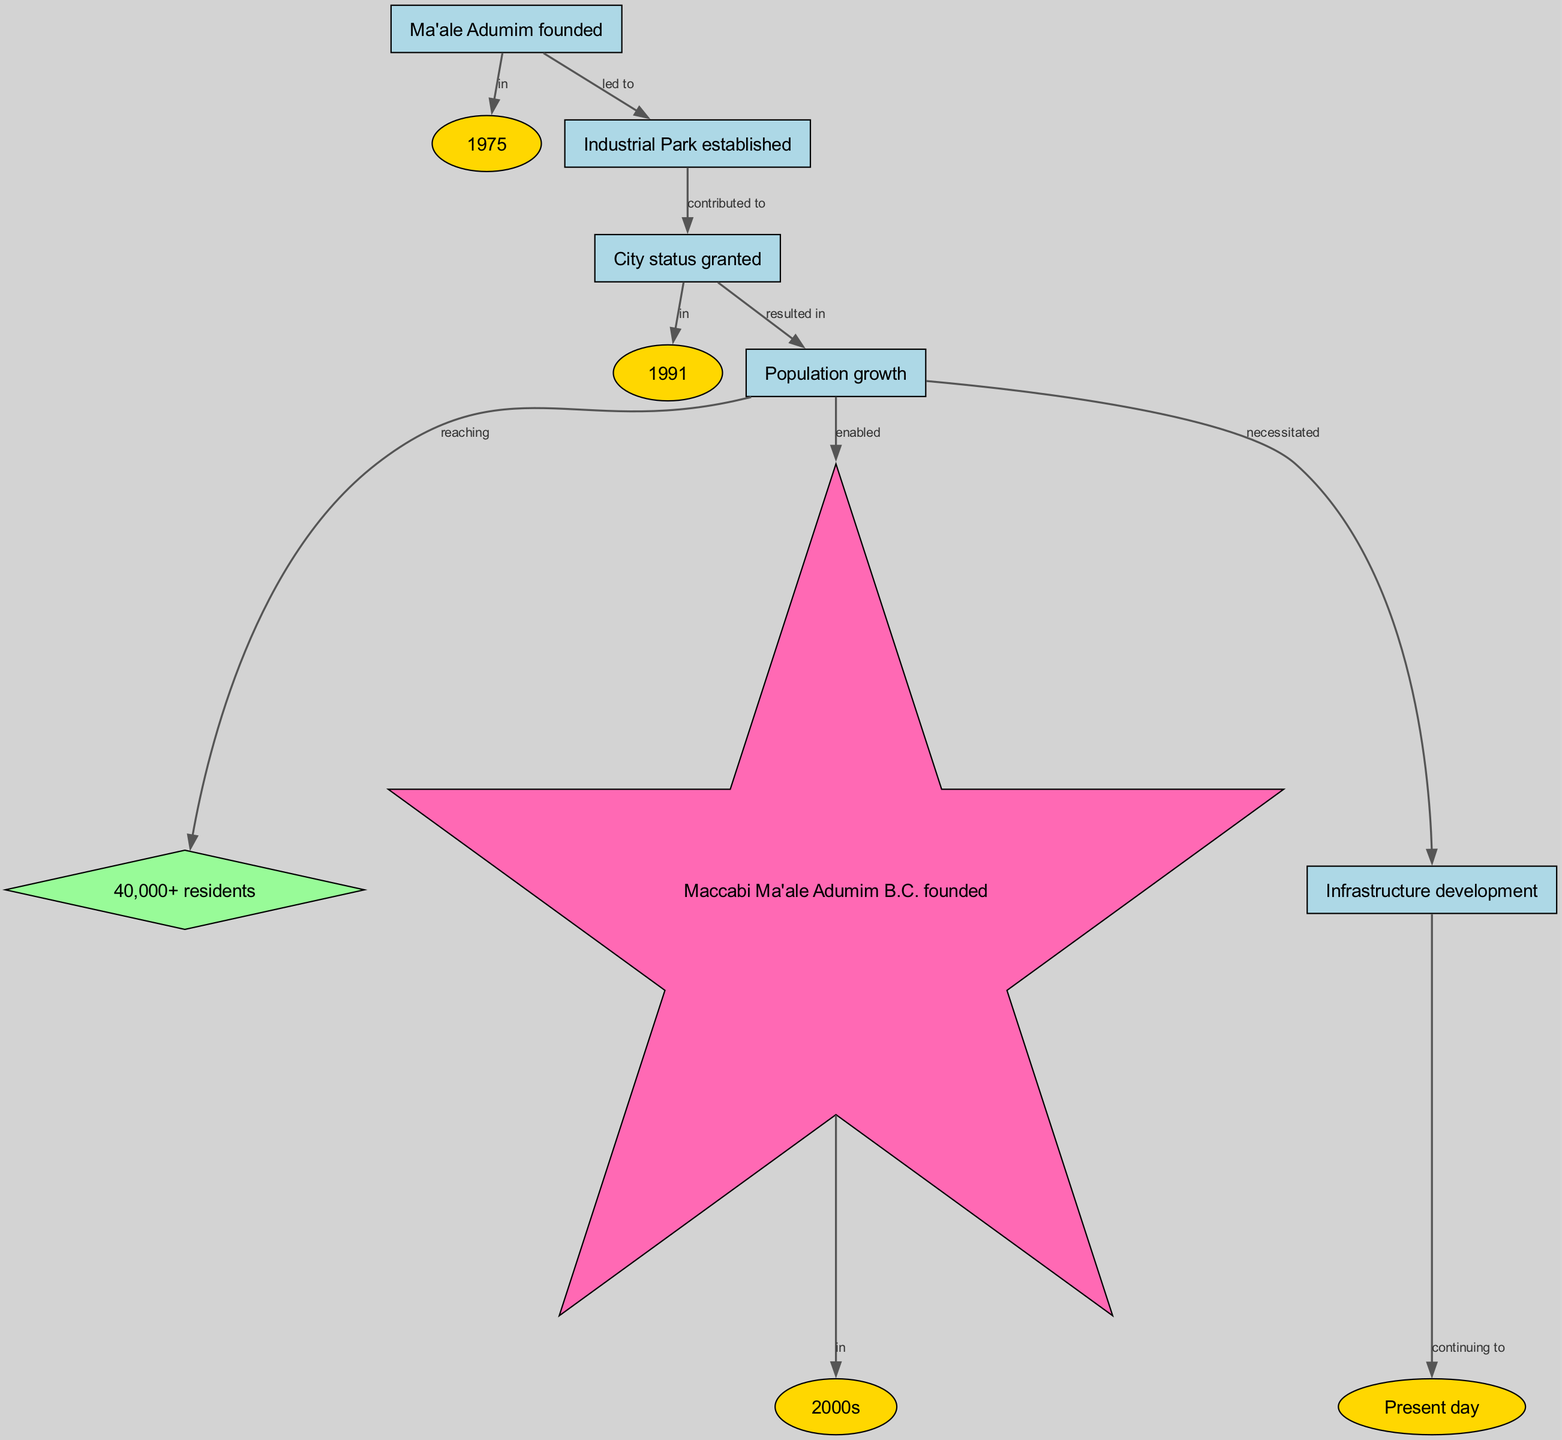What year was Ma'ale Adumim founded? The diagram indicates that Ma'ale Adumim was founded in the year 1975, which is clearly labeled as a time node connected to the founding event.
Answer: 1975 What led to the establishment of the Industrial Park? The diagram shows that the founding of Ma'ale Adumim directly led to the establishment of the Industrial Park, as indicated by the edge labeled "led to."
Answer: Industrial Park established In what year was city status granted to Ma'ale Adumim? According to the diagram, city status was granted in 1991, which is represented as a date node connected to the city status event.
Answer: 1991 What is the estimated population of Ma'ale Adumim? The diagram reveals that the population of Ma'ale Adumim reached over 40,000 residents as depicted in the population growth node connected to the corresponding edge.
Answer: 40,000+ residents What event enabled the founding of Maccabi Ma'ale Adumim B.C.? The diagram indicates that the population growth in Ma'ale Adumim enabled the founding of Maccabi Ma'ale Adumim B.C., linking population increase to the establishment of the basketball club.
Answer: Maccabi Ma'ale Adumim B.C. founded How did the population growth affect infrastructure development? The diagram illustrates that the population growth necessitated infrastructure development, showing a direct connection between these two aspects.
Answer: Necessitated What significant event occurred in the 2000s? The diagram specifically points out that Maccabi Ma'ale Adumim B.C. was founded in the 2000s, marking a notable event within that time period.
Answer: Maccabi Ma'ale Adumim B.C. founded What continues to happen in the present day according to the diagram? The diagram concludes by stating that infrastructure development continues to happen in the present day, which is linked to the ongoing progress of the city.
Answer: Continuing to How did city status impact population growth? The diagram shows that being granted city status contributed to the subsequent population growth of Ma'ale Adumim, indicating a causal relationship depicted by the edges.
Answer: Resulted in 